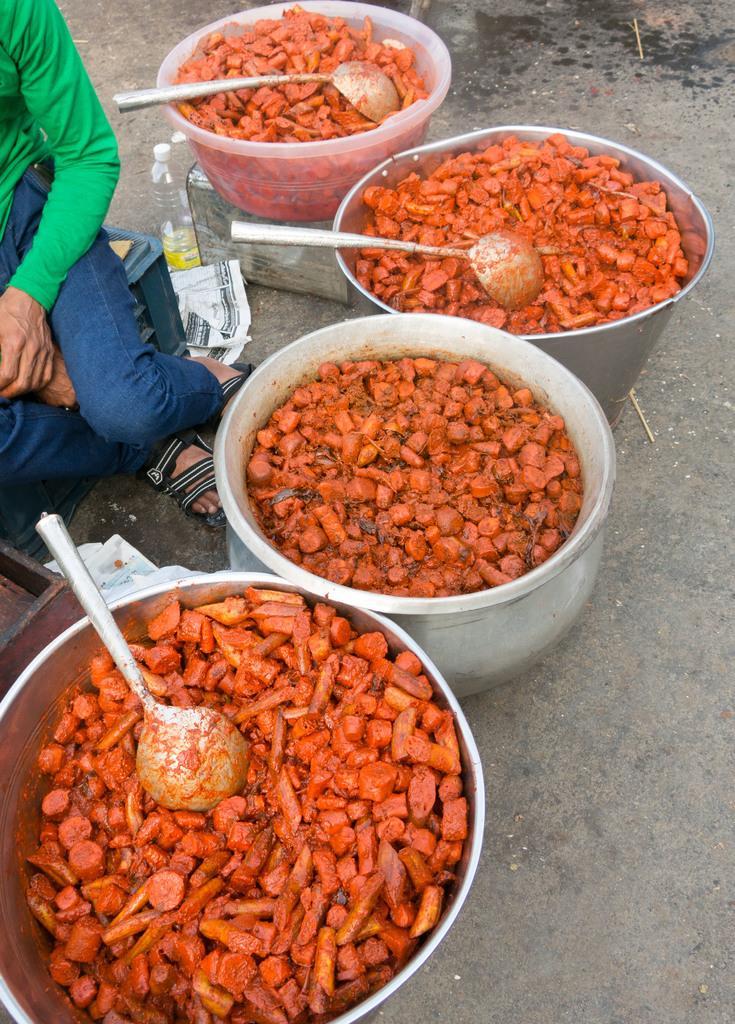How would you summarize this image in a sentence or two? In this image I can see few utensils, spoons and in these utensils I can see number of orange colour things. I can also see a paper, a bottle and here I can see a person is sitting. I can see this person is wearing green dress, blue jeans and sandals. 